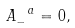<formula> <loc_0><loc_0><loc_500><loc_500>A _ { - } ^ { \ a } = 0 ,</formula> 